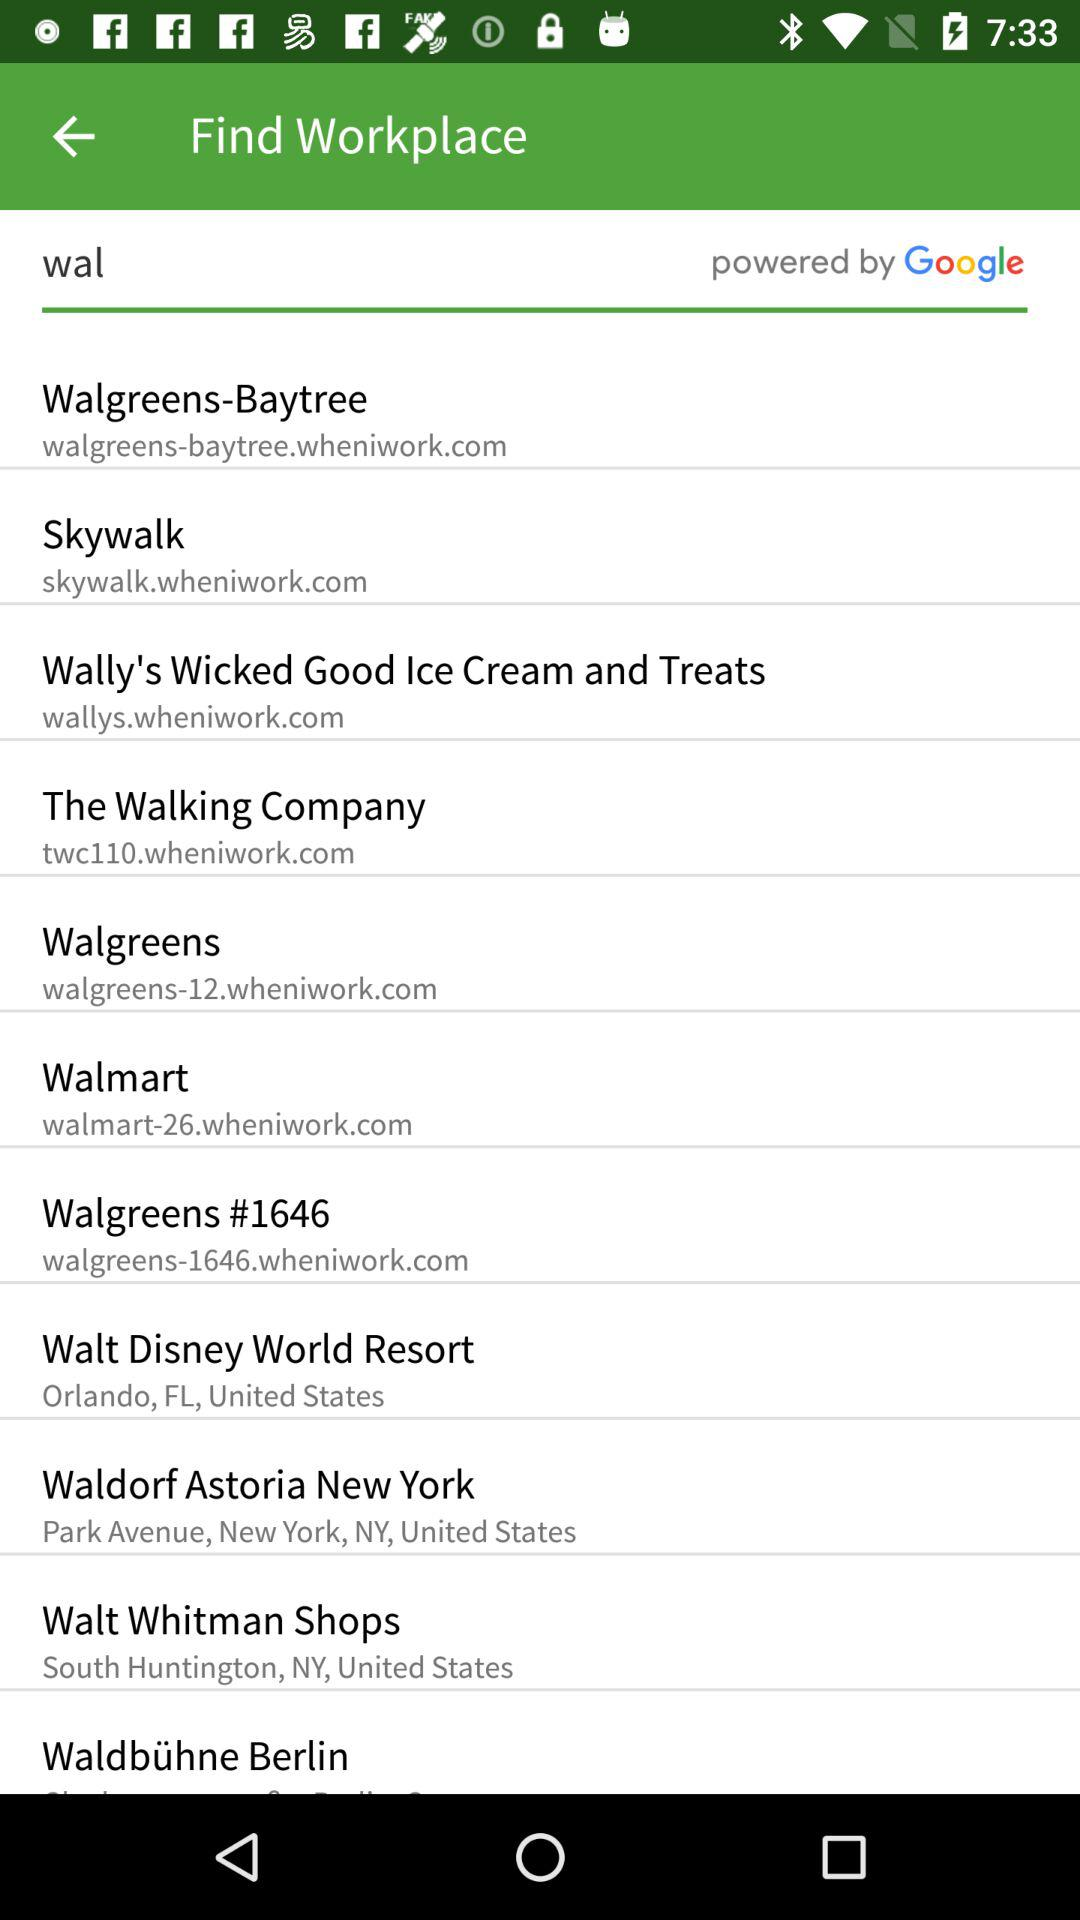What is the URL address of the skywalk? The URL address is skywalk.wheniwork.com. 